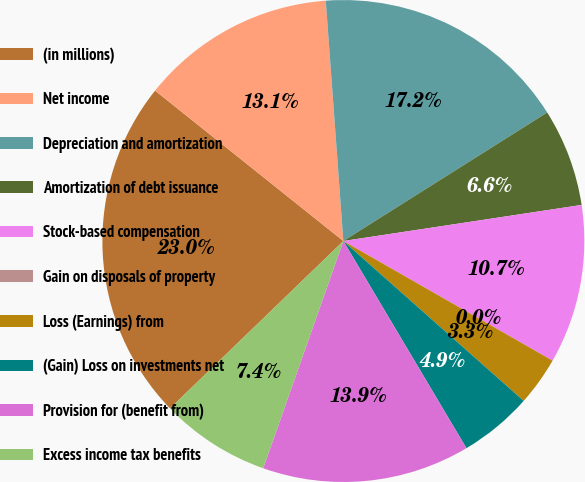Convert chart to OTSL. <chart><loc_0><loc_0><loc_500><loc_500><pie_chart><fcel>(in millions)<fcel>Net income<fcel>Depreciation and amortization<fcel>Amortization of debt issuance<fcel>Stock-based compensation<fcel>Gain on disposals of property<fcel>Loss (Earnings) from<fcel>(Gain) Loss on investments net<fcel>Provision for (benefit from)<fcel>Excess income tax benefits<nl><fcel>22.95%<fcel>13.11%<fcel>17.21%<fcel>6.56%<fcel>10.66%<fcel>0.0%<fcel>3.28%<fcel>4.92%<fcel>13.93%<fcel>7.38%<nl></chart> 